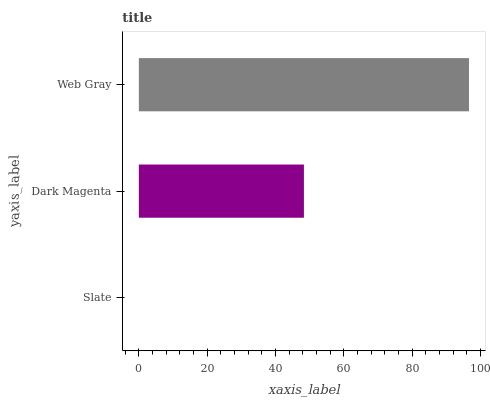Is Slate the minimum?
Answer yes or no. Yes. Is Web Gray the maximum?
Answer yes or no. Yes. Is Dark Magenta the minimum?
Answer yes or no. No. Is Dark Magenta the maximum?
Answer yes or no. No. Is Dark Magenta greater than Slate?
Answer yes or no. Yes. Is Slate less than Dark Magenta?
Answer yes or no. Yes. Is Slate greater than Dark Magenta?
Answer yes or no. No. Is Dark Magenta less than Slate?
Answer yes or no. No. Is Dark Magenta the high median?
Answer yes or no. Yes. Is Dark Magenta the low median?
Answer yes or no. Yes. Is Web Gray the high median?
Answer yes or no. No. Is Slate the low median?
Answer yes or no. No. 